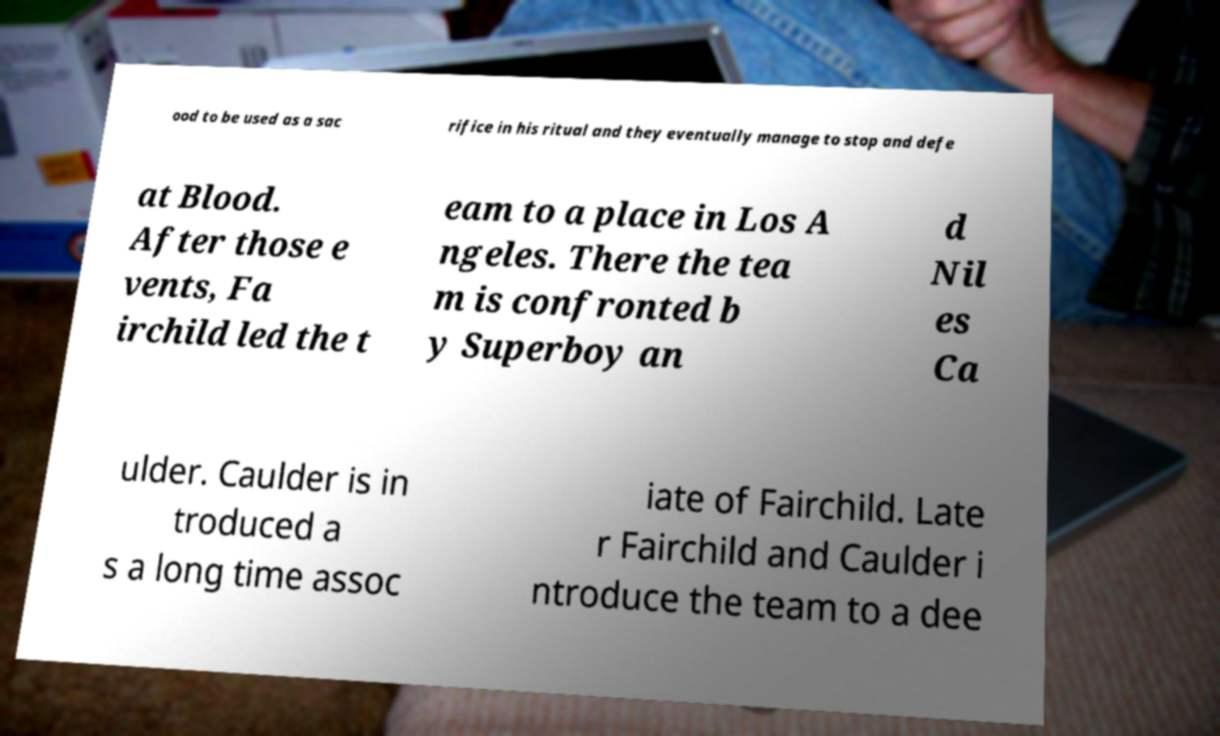Could you extract and type out the text from this image? ood to be used as a sac rifice in his ritual and they eventually manage to stop and defe at Blood. After those e vents, Fa irchild led the t eam to a place in Los A ngeles. There the tea m is confronted b y Superboy an d Nil es Ca ulder. Caulder is in troduced a s a long time assoc iate of Fairchild. Late r Fairchild and Caulder i ntroduce the team to a dee 